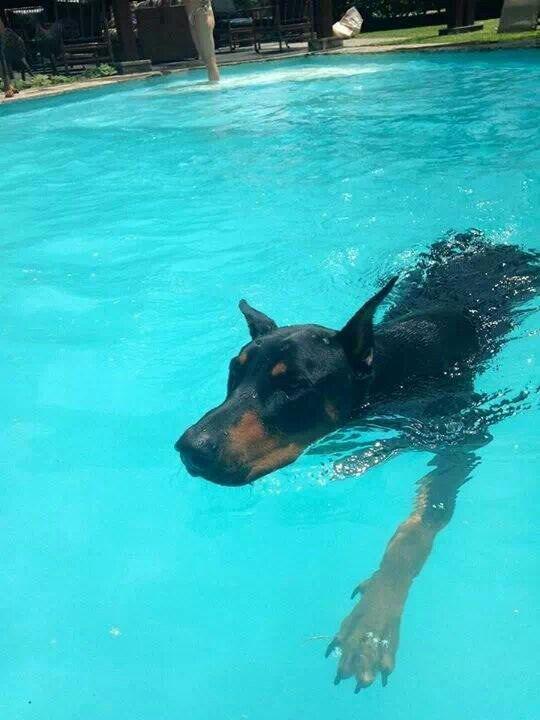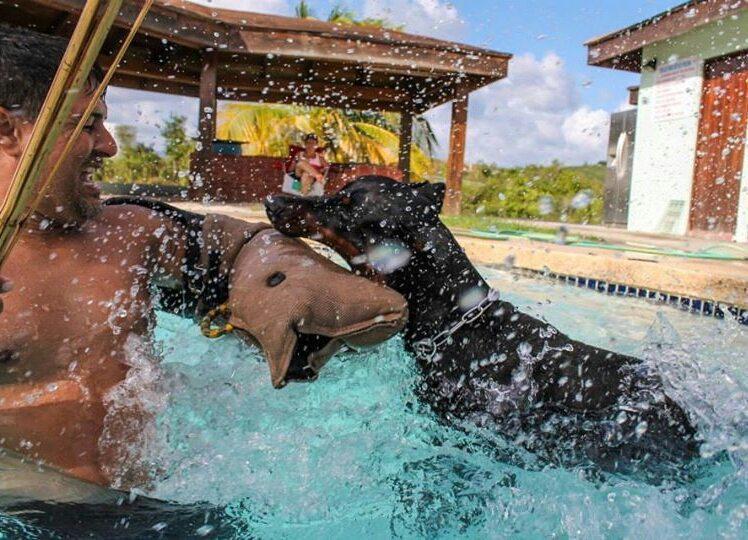The first image is the image on the left, the second image is the image on the right. Considering the images on both sides, is "Both dogs are swimming in a pool and neither is sitting on a float." valid? Answer yes or no. Yes. The first image is the image on the left, the second image is the image on the right. Evaluate the accuracy of this statement regarding the images: "A man is in a pool interacting with a doberman in one image, and the other shows a doberman by itself in water.". Is it true? Answer yes or no. Yes. 